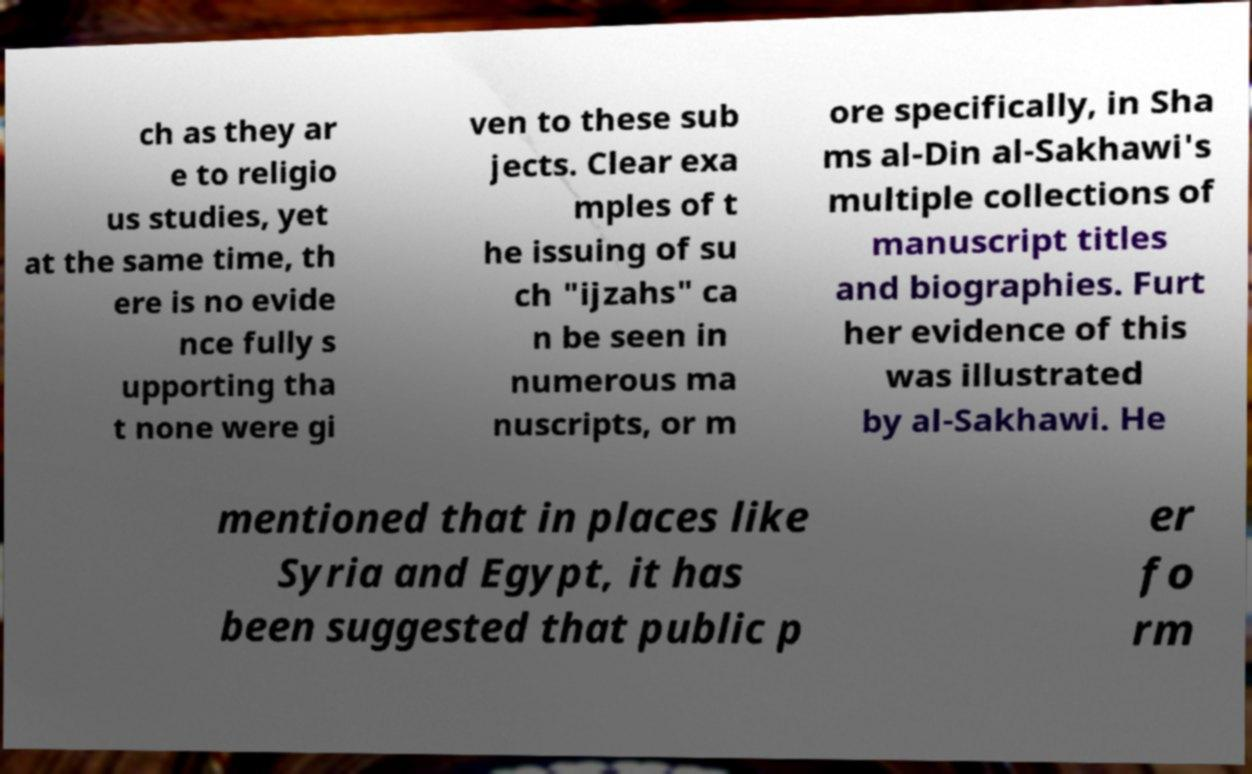Could you assist in decoding the text presented in this image and type it out clearly? ch as they ar e to religio us studies, yet at the same time, th ere is no evide nce fully s upporting tha t none were gi ven to these sub jects. Clear exa mples of t he issuing of su ch "ijzahs" ca n be seen in numerous ma nuscripts, or m ore specifically, in Sha ms al-Din al-Sakhawi's multiple collections of manuscript titles and biographies. Furt her evidence of this was illustrated by al-Sakhawi. He mentioned that in places like Syria and Egypt, it has been suggested that public p er fo rm 